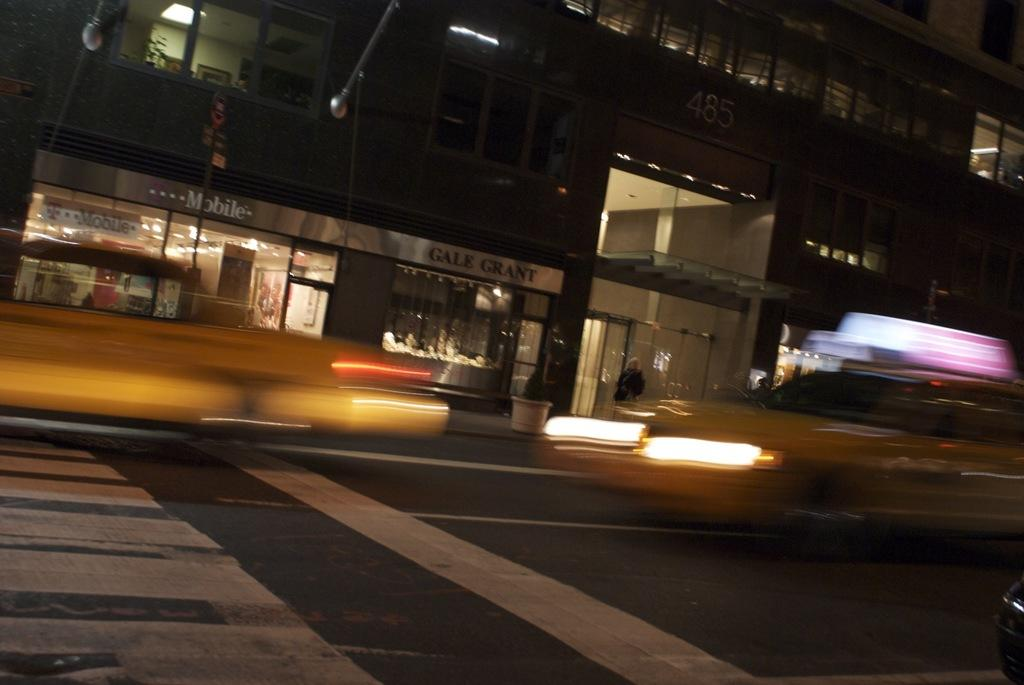What is the main feature of the image? There is a road in the image. What can be seen on the road? There are lights and a flower pot on the road. What type of structure is present in the image? There is a building in the image. What is a feature of the building? There are windows on the building. What else is visible in the image? There is a vehicle and glasses visible in the image. Where is the hook located in the image? There is no hook present in the image. What type of dock can be seen in the image? There is no dock present in the image. 